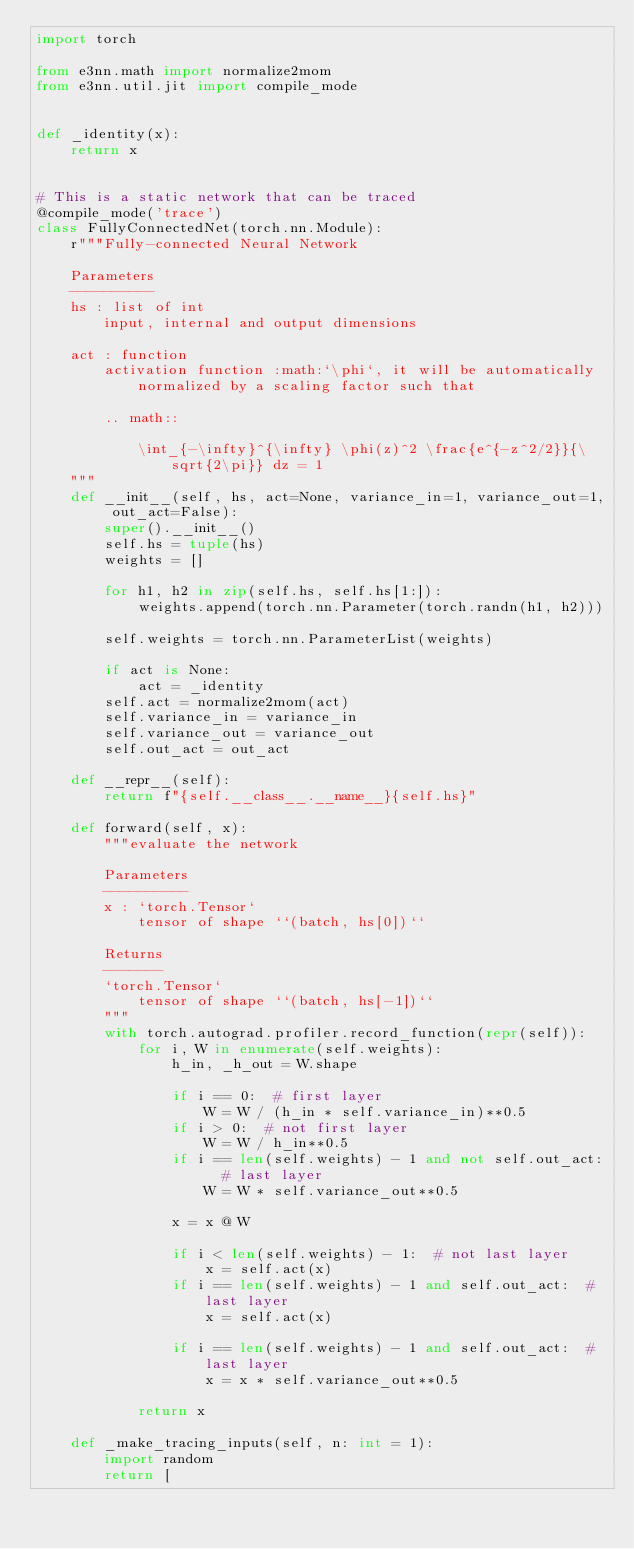<code> <loc_0><loc_0><loc_500><loc_500><_Python_>import torch

from e3nn.math import normalize2mom
from e3nn.util.jit import compile_mode


def _identity(x):
    return x


# This is a static network that can be traced
@compile_mode('trace')
class FullyConnectedNet(torch.nn.Module):
    r"""Fully-connected Neural Network

    Parameters
    ----------
    hs : list of int
        input, internal and output dimensions

    act : function
        activation function :math:`\phi`, it will be automatically normalized by a scaling factor such that

        .. math::

            \int_{-\infty}^{\infty} \phi(z)^2 \frac{e^{-z^2/2}}{\sqrt{2\pi}} dz = 1
    """
    def __init__(self, hs, act=None, variance_in=1, variance_out=1, out_act=False):
        super().__init__()
        self.hs = tuple(hs)
        weights = []

        for h1, h2 in zip(self.hs, self.hs[1:]):
            weights.append(torch.nn.Parameter(torch.randn(h1, h2)))

        self.weights = torch.nn.ParameterList(weights)

        if act is None:
            act = _identity
        self.act = normalize2mom(act)
        self.variance_in = variance_in
        self.variance_out = variance_out
        self.out_act = out_act

    def __repr__(self):
        return f"{self.__class__.__name__}{self.hs}"

    def forward(self, x):
        """evaluate the network

        Parameters
        ----------
        x : `torch.Tensor`
            tensor of shape ``(batch, hs[0])``

        Returns
        -------
        `torch.Tensor`
            tensor of shape ``(batch, hs[-1])``
        """
        with torch.autograd.profiler.record_function(repr(self)):
            for i, W in enumerate(self.weights):
                h_in, _h_out = W.shape

                if i == 0:  # first layer
                    W = W / (h_in * self.variance_in)**0.5
                if i > 0:  # not first layer
                    W = W / h_in**0.5
                if i == len(self.weights) - 1 and not self.out_act:  # last layer
                    W = W * self.variance_out**0.5

                x = x @ W

                if i < len(self.weights) - 1:  # not last layer
                    x = self.act(x)
                if i == len(self.weights) - 1 and self.out_act:  # last layer
                    x = self.act(x)

                if i == len(self.weights) - 1 and self.out_act:  # last layer
                    x = x * self.variance_out**0.5

            return x

    def _make_tracing_inputs(self, n: int = 1):
        import random
        return [</code> 